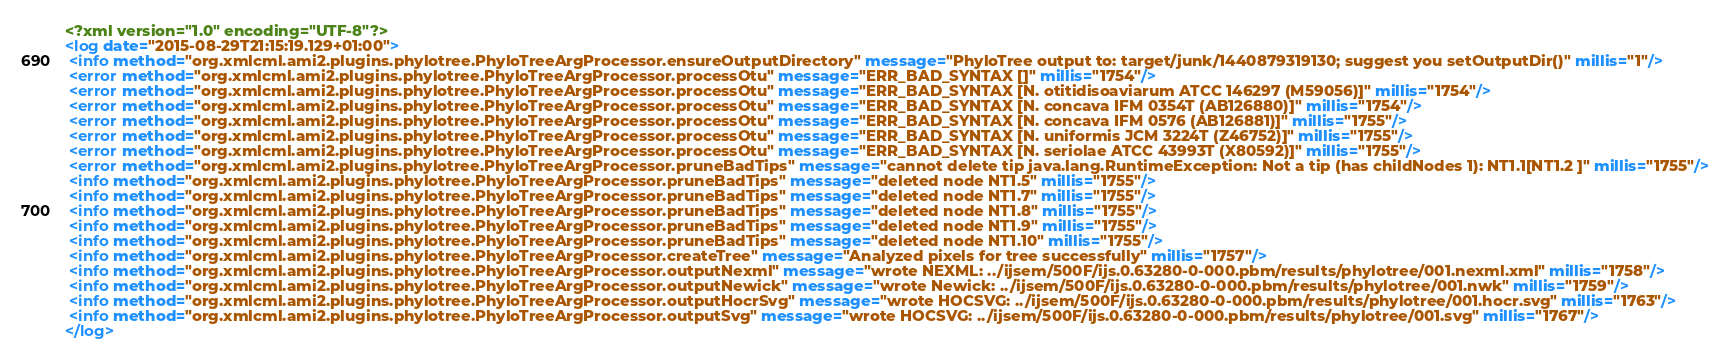<code> <loc_0><loc_0><loc_500><loc_500><_XML_><?xml version="1.0" encoding="UTF-8"?>
<log date="2015-08-29T21:15:19.129+01:00">
 <info method="org.xmlcml.ami2.plugins.phylotree.PhyloTreeArgProcessor.ensureOutputDirectory" message="PhyloTree output to: target/junk/1440879319130; suggest you setOutputDir()" millis="1"/>
 <error method="org.xmlcml.ami2.plugins.phylotree.PhyloTreeArgProcessor.processOtu" message="ERR_BAD_SYNTAX []" millis="1754"/>
 <error method="org.xmlcml.ami2.plugins.phylotree.PhyloTreeArgProcessor.processOtu" message="ERR_BAD_SYNTAX [N. otitidisoaviarum ATCC 146297 (M59056)]" millis="1754"/>
 <error method="org.xmlcml.ami2.plugins.phylotree.PhyloTreeArgProcessor.processOtu" message="ERR_BAD_SYNTAX [N. concava IFM 0354T (AB126880)]" millis="1754"/>
 <error method="org.xmlcml.ami2.plugins.phylotree.PhyloTreeArgProcessor.processOtu" message="ERR_BAD_SYNTAX [N. concava IFM 0576 (AB126881)]" millis="1755"/>
 <error method="org.xmlcml.ami2.plugins.phylotree.PhyloTreeArgProcessor.processOtu" message="ERR_BAD_SYNTAX [N. uniformis JCM 3224T (Z46752)]" millis="1755"/>
 <error method="org.xmlcml.ami2.plugins.phylotree.PhyloTreeArgProcessor.processOtu" message="ERR_BAD_SYNTAX [N. seriolae ATCC 43993T (X80592)]" millis="1755"/>
 <error method="org.xmlcml.ami2.plugins.phylotree.PhyloTreeArgProcessor.pruneBadTips" message="cannot delete tip java.lang.RuntimeException: Not a tip (has childNodes 1): NT1.1[NT1.2 ]" millis="1755"/>
 <info method="org.xmlcml.ami2.plugins.phylotree.PhyloTreeArgProcessor.pruneBadTips" message="deleted node NT1.5" millis="1755"/>
 <info method="org.xmlcml.ami2.plugins.phylotree.PhyloTreeArgProcessor.pruneBadTips" message="deleted node NT1.7" millis="1755"/>
 <info method="org.xmlcml.ami2.plugins.phylotree.PhyloTreeArgProcessor.pruneBadTips" message="deleted node NT1.8" millis="1755"/>
 <info method="org.xmlcml.ami2.plugins.phylotree.PhyloTreeArgProcessor.pruneBadTips" message="deleted node NT1.9" millis="1755"/>
 <info method="org.xmlcml.ami2.plugins.phylotree.PhyloTreeArgProcessor.pruneBadTips" message="deleted node NT1.10" millis="1755"/>
 <info method="org.xmlcml.ami2.plugins.phylotree.PhyloTreeArgProcessor.createTree" message="Analyzed pixels for tree successfully" millis="1757"/>
 <info method="org.xmlcml.ami2.plugins.phylotree.PhyloTreeArgProcessor.outputNexml" message="wrote NEXML: ../ijsem/500F/ijs.0.63280-0-000.pbm/results/phylotree/001.nexml.xml" millis="1758"/>
 <info method="org.xmlcml.ami2.plugins.phylotree.PhyloTreeArgProcessor.outputNewick" message="wrote Newick: ../ijsem/500F/ijs.0.63280-0-000.pbm/results/phylotree/001.nwk" millis="1759"/>
 <info method="org.xmlcml.ami2.plugins.phylotree.PhyloTreeArgProcessor.outputHocrSvg" message="wrote HOCSVG: ../ijsem/500F/ijs.0.63280-0-000.pbm/results/phylotree/001.hocr.svg" millis="1763"/>
 <info method="org.xmlcml.ami2.plugins.phylotree.PhyloTreeArgProcessor.outputSvg" message="wrote HOCSVG: ../ijsem/500F/ijs.0.63280-0-000.pbm/results/phylotree/001.svg" millis="1767"/>
</log>
</code> 